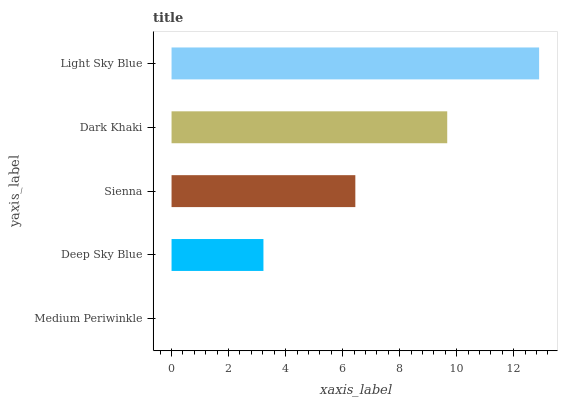Is Medium Periwinkle the minimum?
Answer yes or no. Yes. Is Light Sky Blue the maximum?
Answer yes or no. Yes. Is Deep Sky Blue the minimum?
Answer yes or no. No. Is Deep Sky Blue the maximum?
Answer yes or no. No. Is Deep Sky Blue greater than Medium Periwinkle?
Answer yes or no. Yes. Is Medium Periwinkle less than Deep Sky Blue?
Answer yes or no. Yes. Is Medium Periwinkle greater than Deep Sky Blue?
Answer yes or no. No. Is Deep Sky Blue less than Medium Periwinkle?
Answer yes or no. No. Is Sienna the high median?
Answer yes or no. Yes. Is Sienna the low median?
Answer yes or no. Yes. Is Deep Sky Blue the high median?
Answer yes or no. No. Is Dark Khaki the low median?
Answer yes or no. No. 